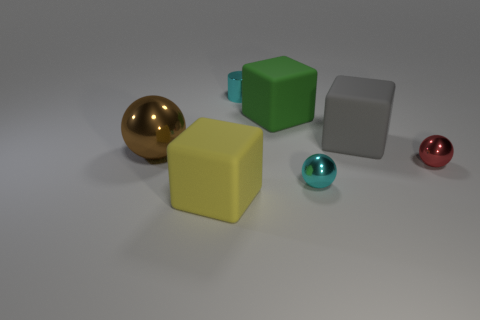There is a small metal thing behind the red ball; is it the same shape as the yellow thing?
Your answer should be compact. No. There is another tiny thing that is the same shape as the tiny red metallic object; what color is it?
Keep it short and to the point. Cyan. Is there any other thing that is the same material as the yellow object?
Keep it short and to the point. Yes. There is a green thing that is the same shape as the big gray matte thing; what is its size?
Keep it short and to the point. Large. What material is the large cube that is behind the small red sphere and left of the cyan ball?
Make the answer very short. Rubber. There is a object left of the big yellow rubber thing; is it the same color as the tiny cylinder?
Provide a short and direct response. No. Does the tiny cylinder have the same color as the large cube that is in front of the big gray rubber block?
Your response must be concise. No. Are there any big brown balls right of the red metal object?
Offer a very short reply. No. Are the big brown object and the big gray thing made of the same material?
Make the answer very short. No. There is a sphere that is the same size as the gray rubber block; what is its material?
Keep it short and to the point. Metal. 